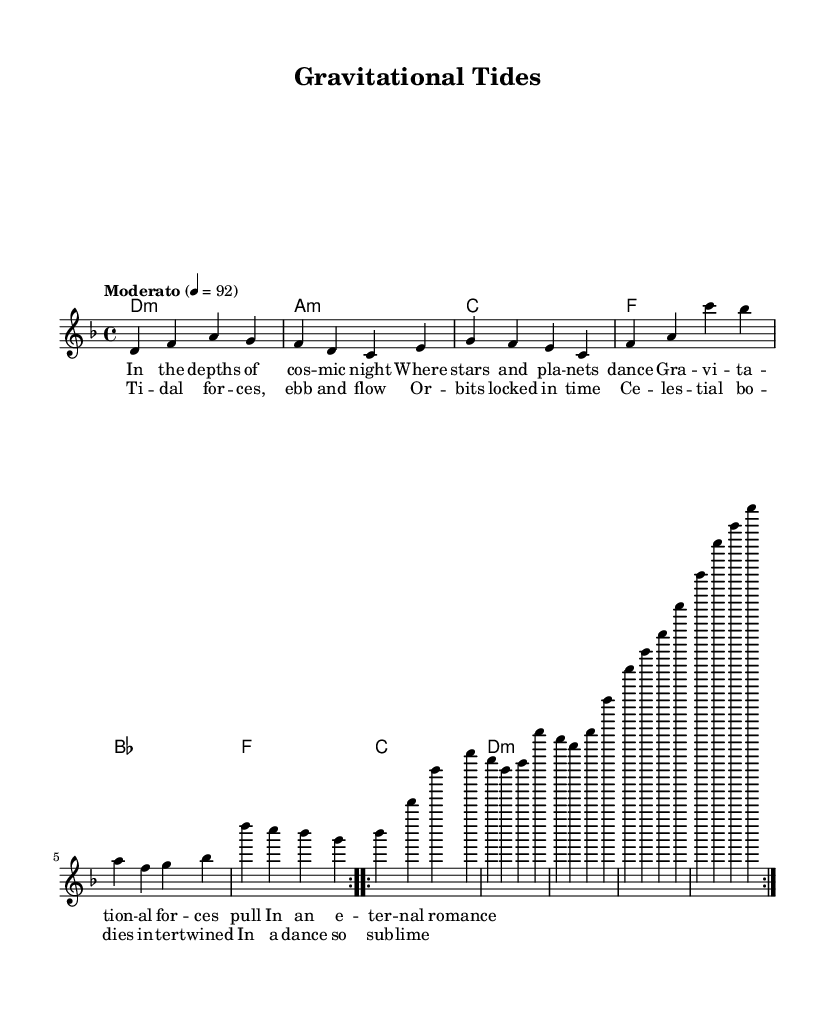What is the key signature of this music? The key signature is indicated by the symbols at the beginning of the staff. In this case, there are no sharps or flats, and since the piece is in D minor, its key signature follows that layout.
Answer: D minor What is the time signature of this music? The time signature is placed at the beginning of the piece, directly after the clef and key signature. Here, it is shown as 4/4, which means there are four beats in each measure and a quarter note gets one beat.
Answer: 4/4 What is the tempo marking for this music? The tempo marking is given in a separate line above the music. It indicates the speed of the piece. In this case, it states "Moderato" with a metronome marking of 92 beats per minute.
Answer: Moderato How many measures are there in the verse? The verse is comprised of two sections, each repeated. Since each section consists of four measures, and with the repeats, this counts to a total of eight measures for the entire verse.
Answer: 8 What type of chord is the first harmony in the piece? The first harmony is indicated in the chord names section. It is marked as "d1:m," which signifies that it is a D minor chord.
Answer: D minor What astronomical concepts are referenced in the lyrics? The lyrics contain terms that refer to celestial phenomena, like "gravitational forces," "celestial bodies," and "tides." These concepts illustrate the theme of the relationship between physics and astronomy.
Answer: Gravitational forces What is the main theme represented in the chorus? The chorus speaks to the interaction between celestial bodies, describing their movements as "dance so sublime," suggesting a harmonious relationship influenced by physics.
Answer: Celestial bodies entwined 